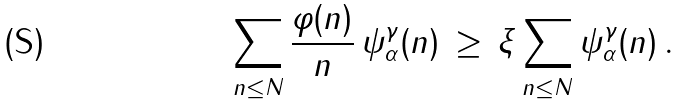<formula> <loc_0><loc_0><loc_500><loc_500>\sum _ { n \leq N } \frac { \varphi ( n ) } { n } \, \psi ^ { \gamma } _ { \alpha } ( n ) \, \geq \, \xi \sum _ { n \leq N } \psi ^ { \gamma } _ { \alpha } ( n ) \, .</formula> 